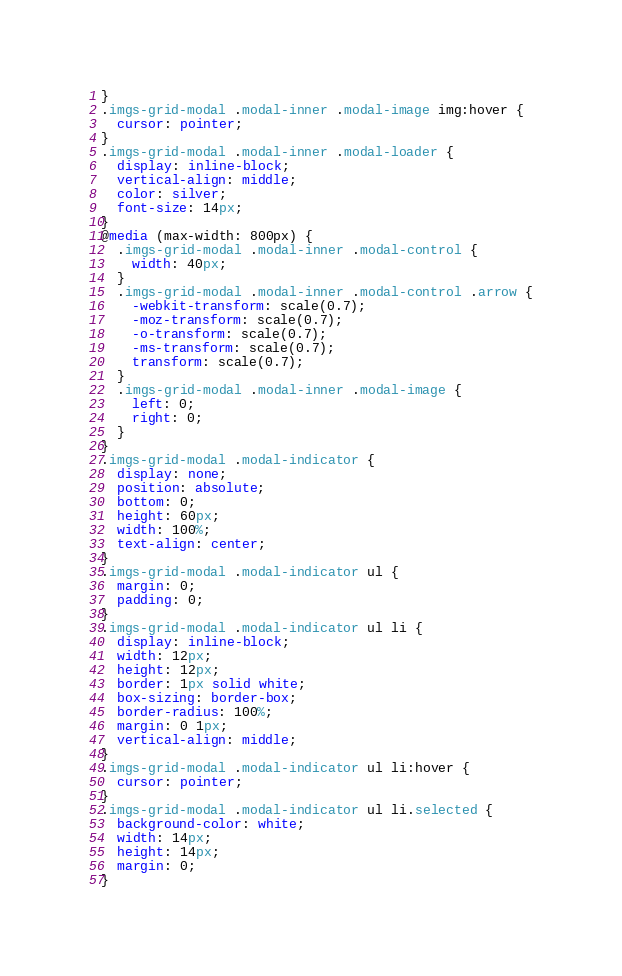<code> <loc_0><loc_0><loc_500><loc_500><_CSS_>}
.imgs-grid-modal .modal-inner .modal-image img:hover {
  cursor: pointer;
}
.imgs-grid-modal .modal-inner .modal-loader {
  display: inline-block;
  vertical-align: middle;
  color: silver;
  font-size: 14px;
}
@media (max-width: 800px) {
  .imgs-grid-modal .modal-inner .modal-control {
    width: 40px;
  }
  .imgs-grid-modal .modal-inner .modal-control .arrow {
    -webkit-transform: scale(0.7);
    -moz-transform: scale(0.7);
    -o-transform: scale(0.7);
    -ms-transform: scale(0.7);
    transform: scale(0.7);
  }
  .imgs-grid-modal .modal-inner .modal-image {
    left: 0;
    right: 0;
  }
}
.imgs-grid-modal .modal-indicator {
  display: none;
  position: absolute;
  bottom: 0;
  height: 60px;
  width: 100%;
  text-align: center;
}
.imgs-grid-modal .modal-indicator ul {
  margin: 0;
  padding: 0;
}
.imgs-grid-modal .modal-indicator ul li {
  display: inline-block;
  width: 12px;
  height: 12px;
  border: 1px solid white;
  box-sizing: border-box;
  border-radius: 100%;
  margin: 0 1px;
  vertical-align: middle;
}
.imgs-grid-modal .modal-indicator ul li:hover {
  cursor: pointer;
}
.imgs-grid-modal .modal-indicator ul li.selected {
  background-color: white;
  width: 14px;
  height: 14px;
  margin: 0;
}
</code> 